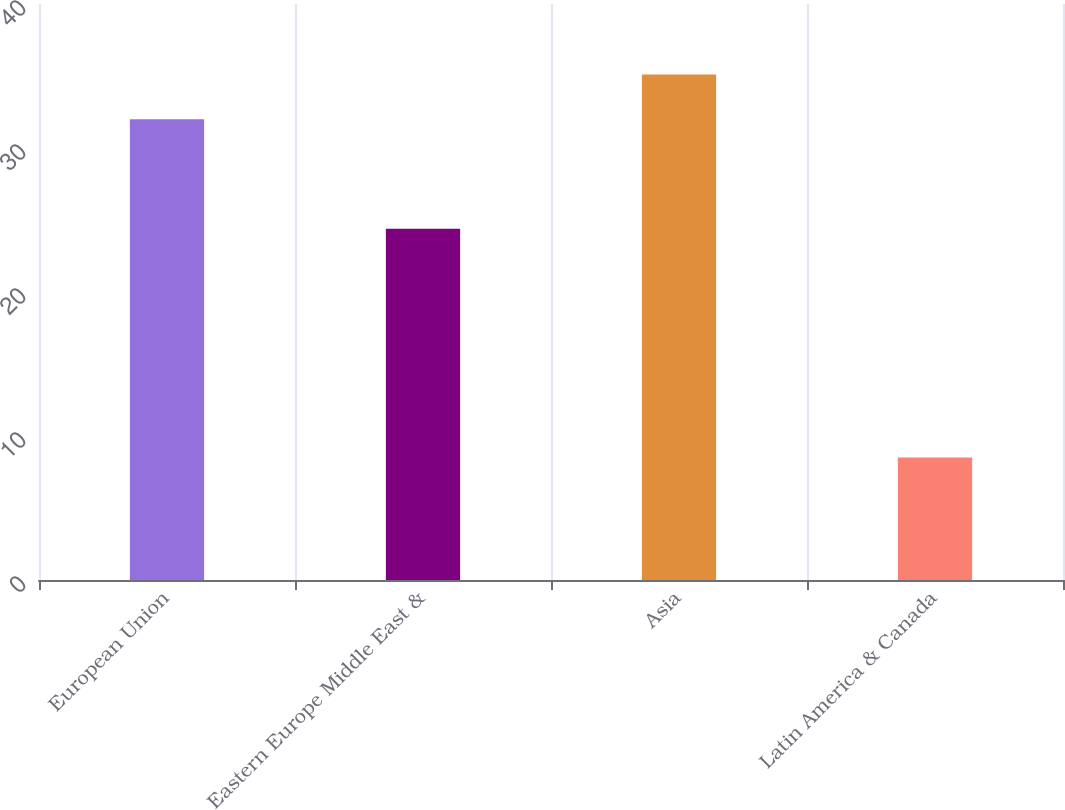Convert chart. <chart><loc_0><loc_0><loc_500><loc_500><bar_chart><fcel>European Union<fcel>Eastern Europe Middle East &<fcel>Asia<fcel>Latin America & Canada<nl><fcel>32<fcel>24.4<fcel>35.1<fcel>8.5<nl></chart> 